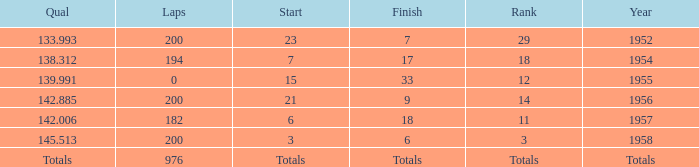What place did Jimmy Reece start from when he ranked 12? 15.0. 